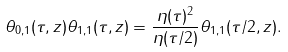<formula> <loc_0><loc_0><loc_500><loc_500>\theta _ { 0 , 1 } ( \tau , z ) \theta _ { 1 , 1 } ( \tau , z ) & = \frac { \eta ( \tau ) ^ { 2 } } { \eta ( \tau / 2 ) } \theta _ { 1 , 1 } ( \tau / 2 , z ) .</formula> 